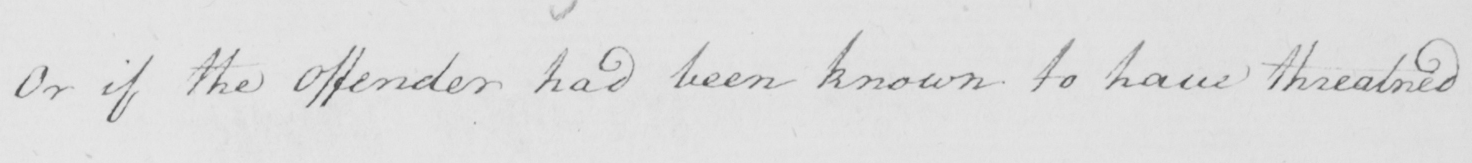Please transcribe the handwritten text in this image. Or if the Offender had been known to have threatned 